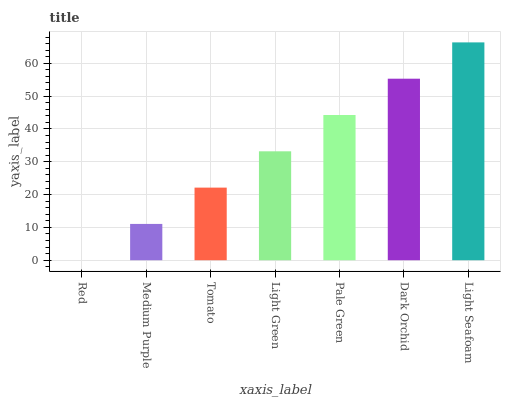Is Red the minimum?
Answer yes or no. Yes. Is Light Seafoam the maximum?
Answer yes or no. Yes. Is Medium Purple the minimum?
Answer yes or no. No. Is Medium Purple the maximum?
Answer yes or no. No. Is Medium Purple greater than Red?
Answer yes or no. Yes. Is Red less than Medium Purple?
Answer yes or no. Yes. Is Red greater than Medium Purple?
Answer yes or no. No. Is Medium Purple less than Red?
Answer yes or no. No. Is Light Green the high median?
Answer yes or no. Yes. Is Light Green the low median?
Answer yes or no. Yes. Is Medium Purple the high median?
Answer yes or no. No. Is Pale Green the low median?
Answer yes or no. No. 